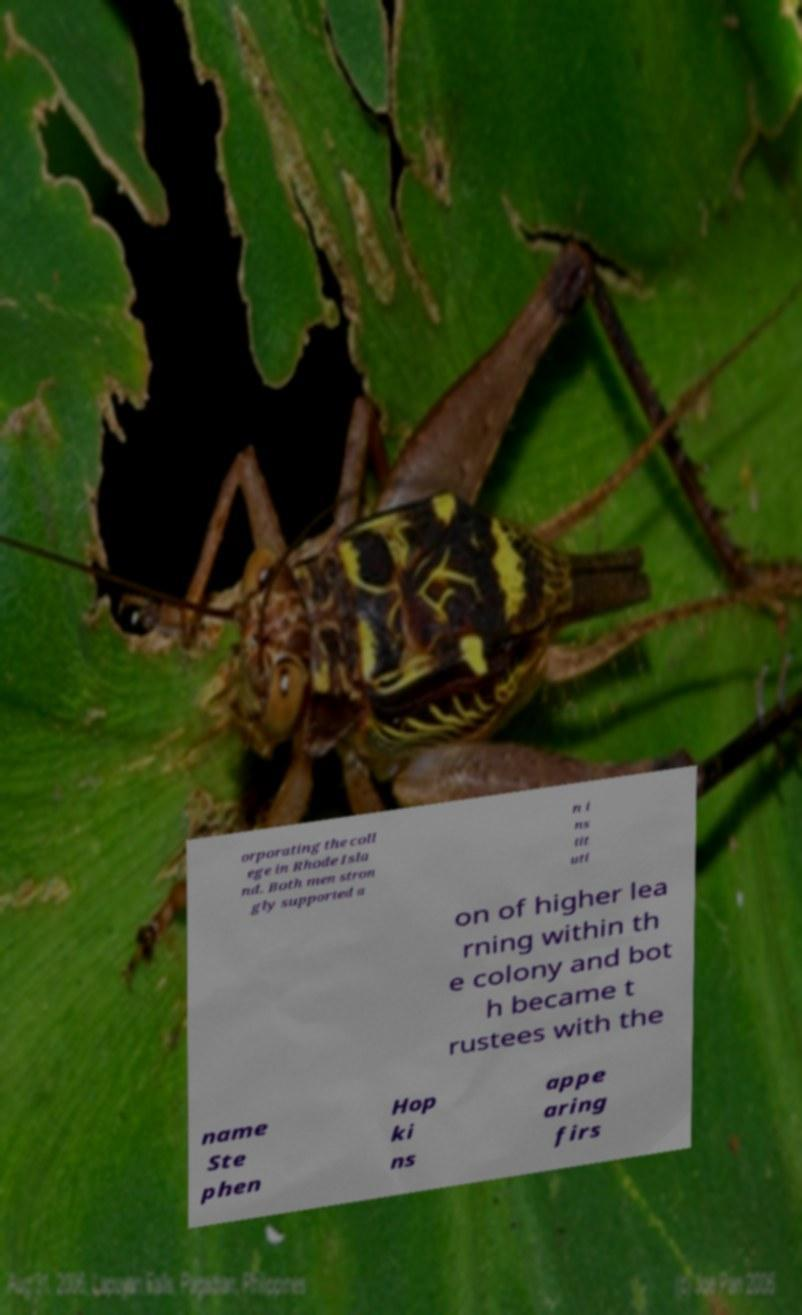Could you extract and type out the text from this image? orporating the coll ege in Rhode Isla nd. Both men stron gly supported a n i ns tit uti on of higher lea rning within th e colony and bot h became t rustees with the name Ste phen Hop ki ns appe aring firs 